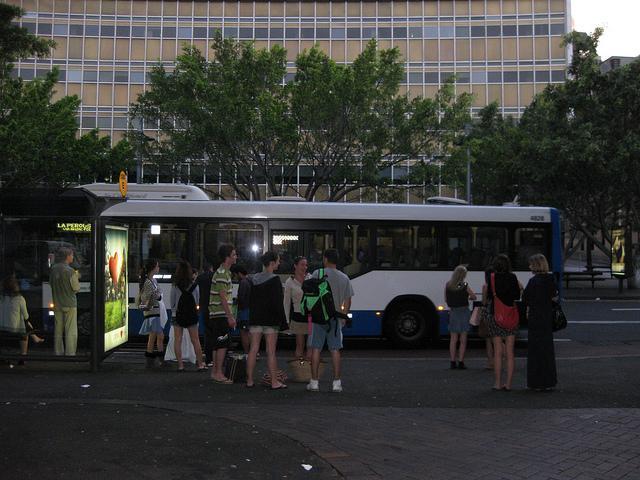Why are they standing on the sidewalk?
Answer the question by selecting the correct answer among the 4 following choices and explain your choice with a short sentence. The answer should be formatted with the following format: `Answer: choice
Rationale: rationale.`
Options: Lost, taking bus, taking cab, socializing. Answer: taking bus.
Rationale: The people are waiting on the sidewalk so they are likely about to board the bus. 